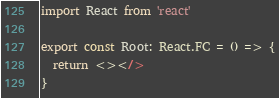<code> <loc_0><loc_0><loc_500><loc_500><_TypeScript_>import React from 'react'

export const Root: React.FC = () => {
  return <></>
}
</code> 